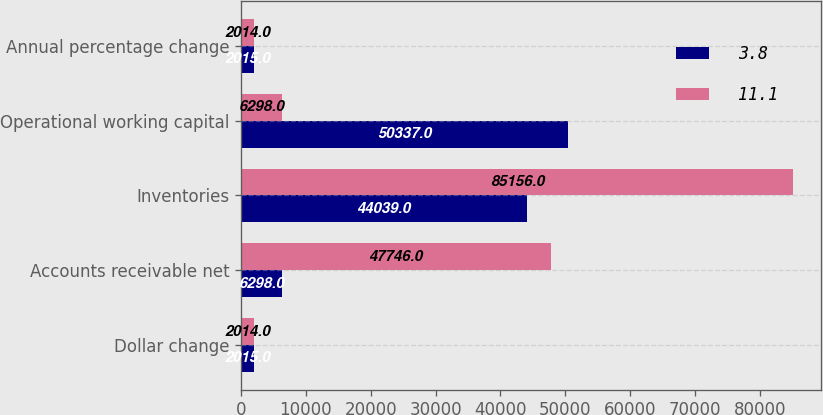Convert chart. <chart><loc_0><loc_0><loc_500><loc_500><stacked_bar_chart><ecel><fcel>Dollar change<fcel>Accounts receivable net<fcel>Inventories<fcel>Operational working capital<fcel>Annual percentage change<nl><fcel>3.8<fcel>2015<fcel>6298<fcel>44039<fcel>50337<fcel>2015<nl><fcel>11.1<fcel>2014<fcel>47746<fcel>85156<fcel>6298<fcel>2014<nl></chart> 